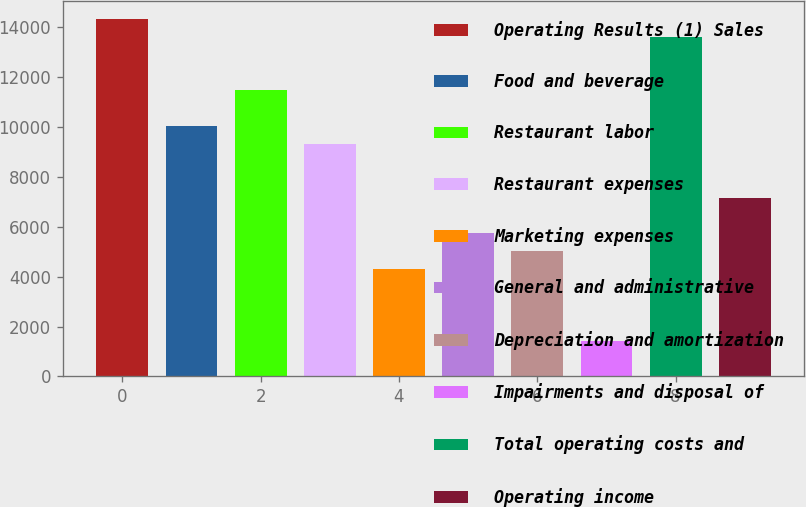<chart> <loc_0><loc_0><loc_500><loc_500><bar_chart><fcel>Operating Results (1) Sales<fcel>Food and beverage<fcel>Restaurant labor<fcel>Restaurant expenses<fcel>Marketing expenses<fcel>General and administrative<fcel>Depreciation and amortization<fcel>Impairments and disposal of<fcel>Total operating costs and<fcel>Operating income<nl><fcel>14340.4<fcel>10038.3<fcel>11472.4<fcel>9321.29<fcel>4302.15<fcel>5736.19<fcel>5019.17<fcel>1434.07<fcel>13623.4<fcel>7170.23<nl></chart> 